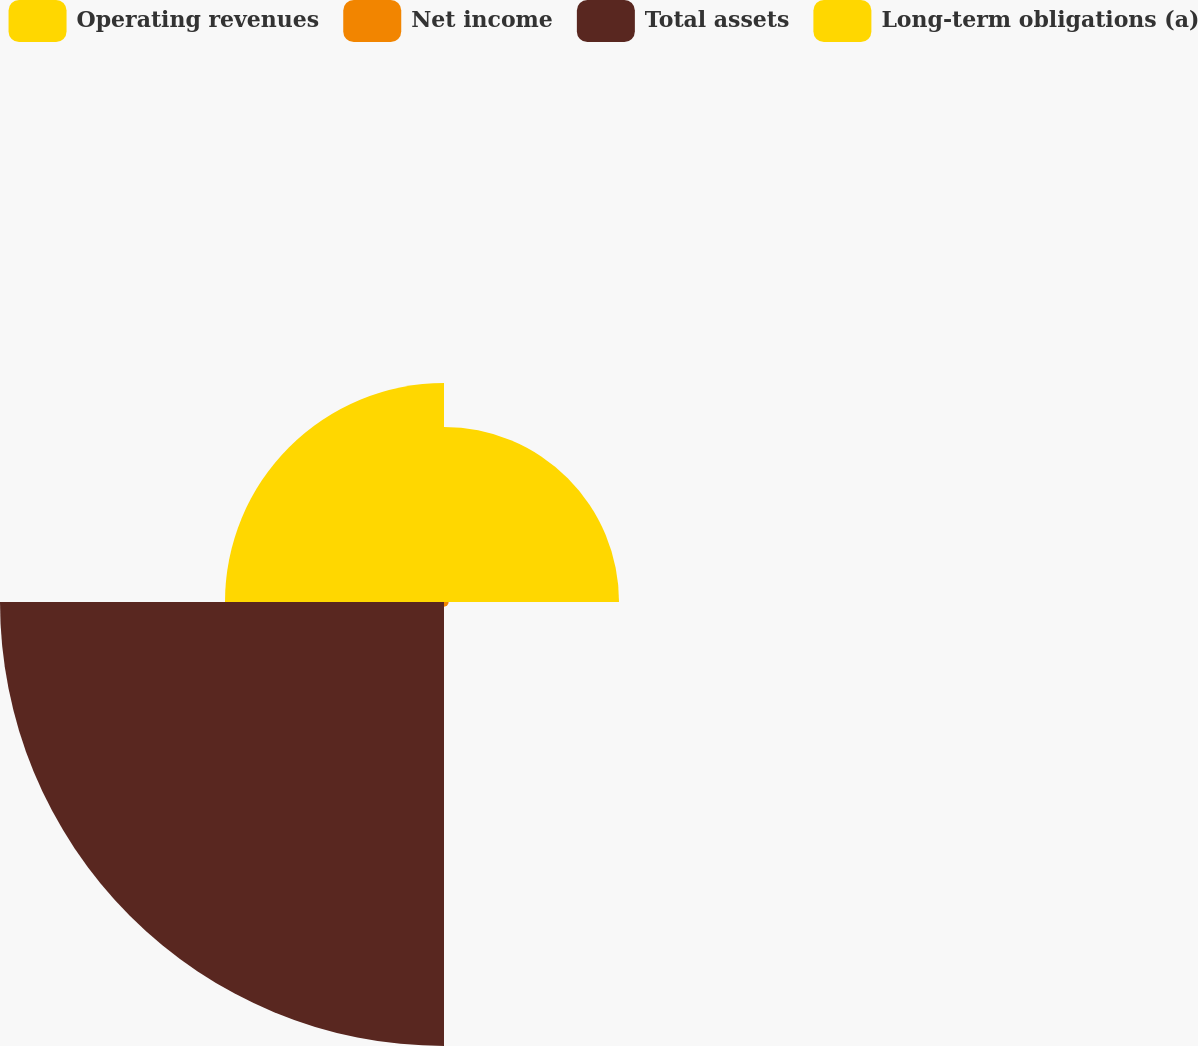<chart> <loc_0><loc_0><loc_500><loc_500><pie_chart><fcel>Operating revenues<fcel>Net income<fcel>Total assets<fcel>Long-term obligations (a)<nl><fcel>20.77%<fcel>0.55%<fcel>52.69%<fcel>25.99%<nl></chart> 